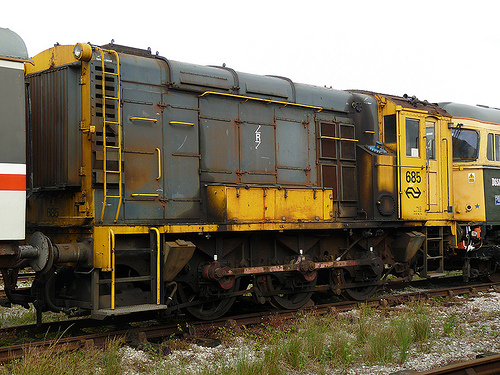Is there a helmet in the image? No, there is no helmet visible in the image. 